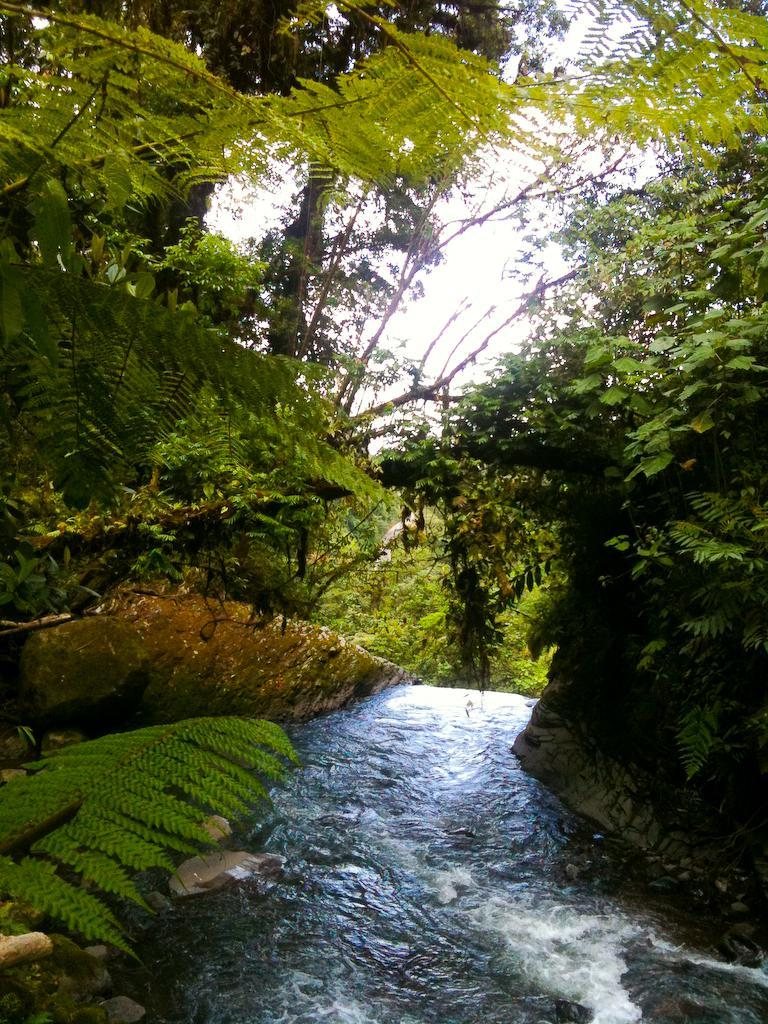What is located in the front of the image? There is a water canal in the front of the image. What type of vegetation is present alongside the water canal? There are trees on both sides of the water canal. What is visible at the top of the image? The sky is visible at the top of the image. What is the opinion of the pencil about the water canal in the image? There is no pencil present in the image, and therefore no opinion can be attributed to it. 